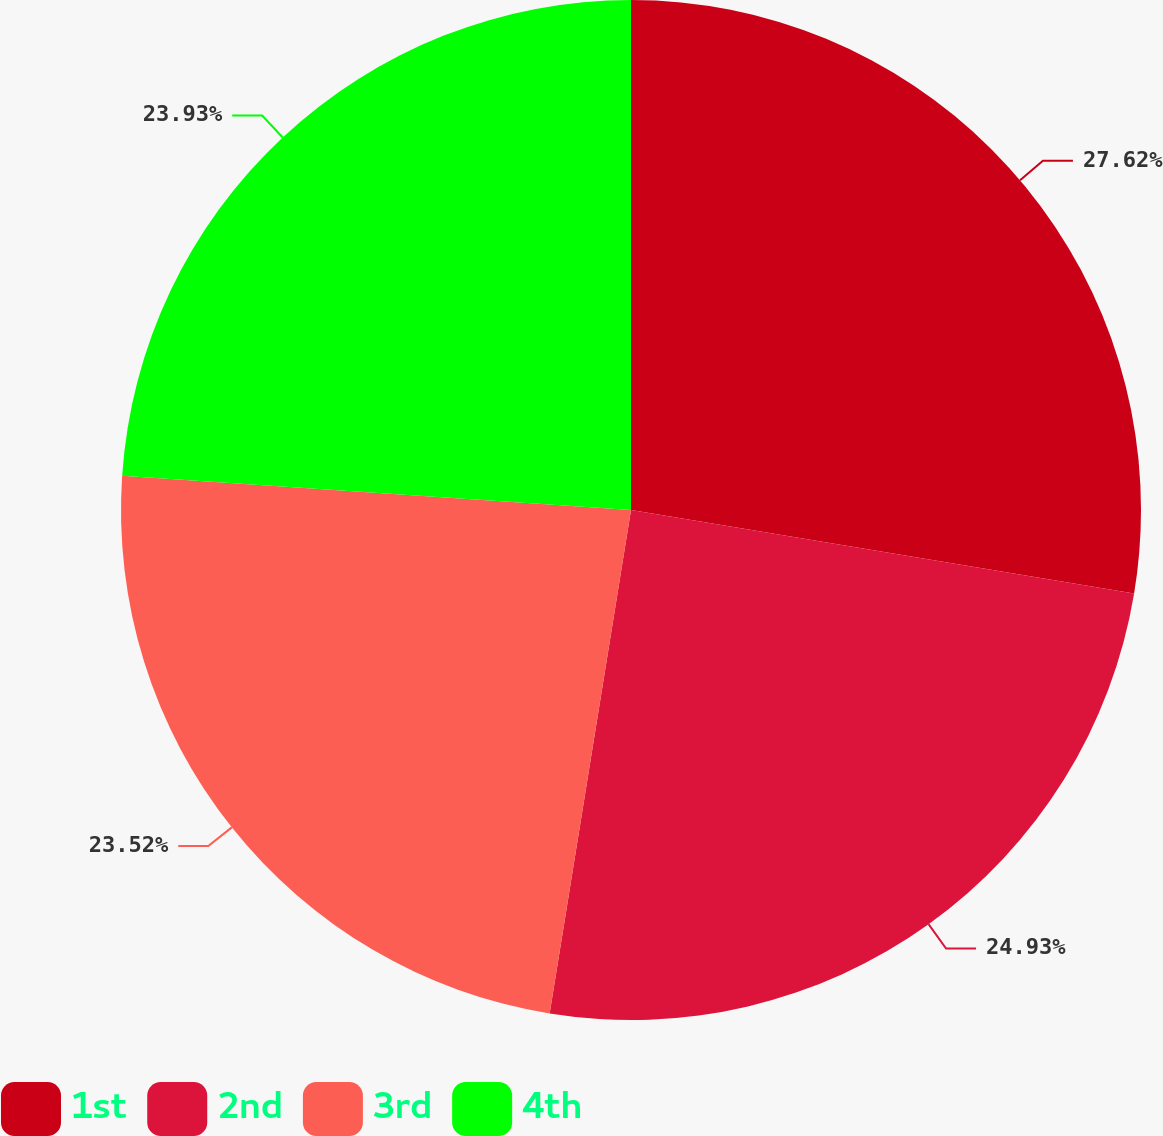<chart> <loc_0><loc_0><loc_500><loc_500><pie_chart><fcel>1st<fcel>2nd<fcel>3rd<fcel>4th<nl><fcel>27.62%<fcel>24.93%<fcel>23.52%<fcel>23.93%<nl></chart> 